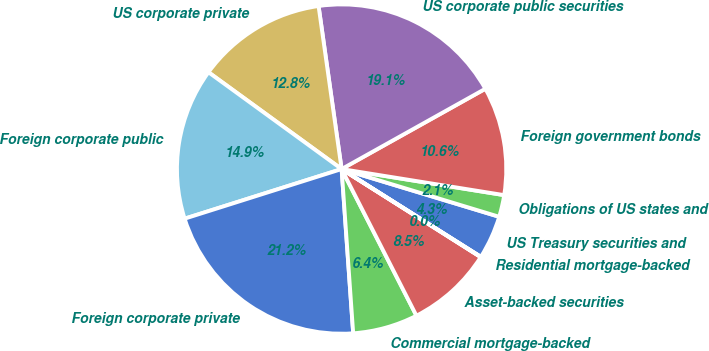Convert chart. <chart><loc_0><loc_0><loc_500><loc_500><pie_chart><fcel>US Treasury securities and<fcel>Obligations of US states and<fcel>Foreign government bonds<fcel>US corporate public securities<fcel>US corporate private<fcel>Foreign corporate public<fcel>Foreign corporate private<fcel>Commercial mortgage-backed<fcel>Asset-backed securities<fcel>Residential mortgage-backed<nl><fcel>4.27%<fcel>2.15%<fcel>10.64%<fcel>19.13%<fcel>12.76%<fcel>14.88%<fcel>21.25%<fcel>6.39%<fcel>8.51%<fcel>0.03%<nl></chart> 